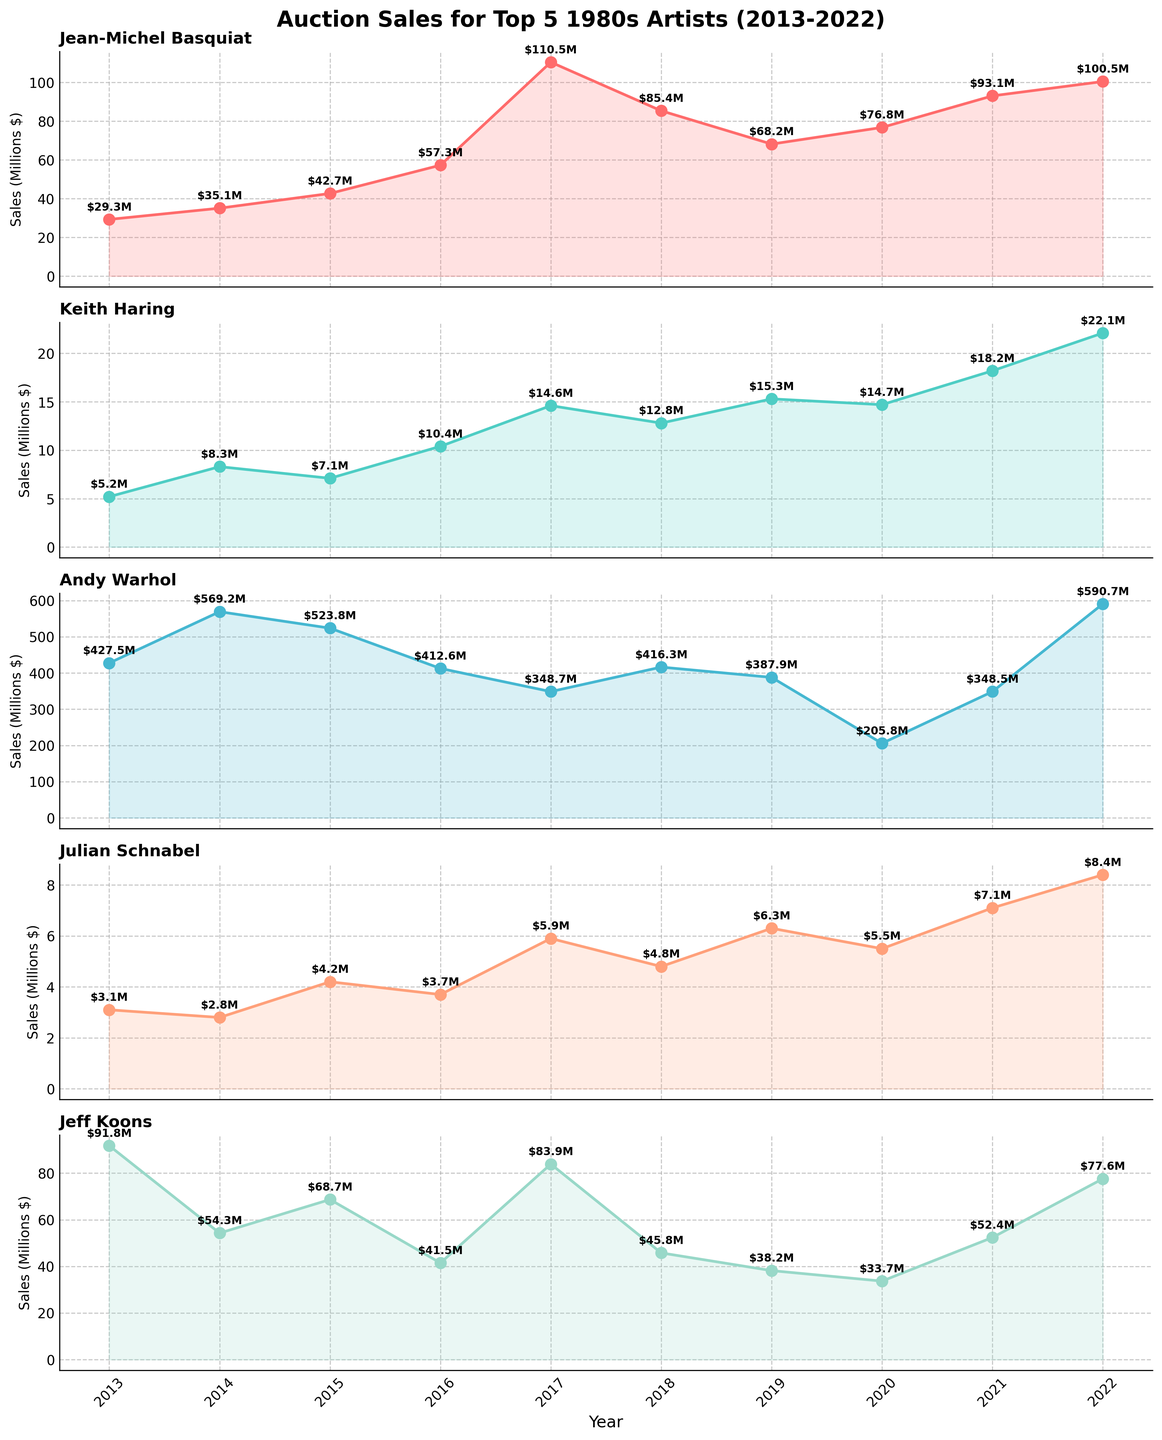What is the title of the figure? The title of the figure is located at the top and summarizes the purpose or content of the figure. It reads "Auction Sales for Top 5 1980s Artists (2013-2022)".
Answer: Auction Sales for Top 5 1980s Artists (2013-2022) What is the sales value for Jean-Michel Basquiat in 2018? Find the plot for Jean-Michel Basquiat, then locate the point for the year 2018 on the x-axis. The corresponding sales value can be read directly from the y-axis. In 2018, it’s marked as $85.4M.
Answer: $85.4M Which artist had the highest auction sales in 2022? Compare the sales values for 2022 for each artist by looking at the end of each subplot. Andy Warhol’s sales were the highest with a value of $590.7M in 2022.
Answer: Andy Warhol On average, how much did Keith Haring’s auction sales increase per year from 2013 to 2022? To find the average yearly increase, subtract the 2013 sales value from the 2022 sales value and divide by the number of years (2022-2013 = 9 years). The calculation is ($22.1M - $5.2M) / 9 years = $1.8778M per year.
Answer: $1.8778M per year Which two artists experienced the most significant drop in auction sales in any single year? By examining each subplot, identify where the most significant year-over-year drop occurred. Andy Warhol had a significant drop from 2018 to 2019 ($416.3M to $205.8M), and Jeff Koons from 2017 to 2018 ($83.9M to $45.8M).
Answer: Andy Warhol, Jeff Koons What was the total sales value for Andy Warhol over the decade? Sum the annual sales values from 2013 to 2022 for Andy Warhol: $427.5M + $569.2M + $523.8M + $412.6M + $348.7M + $416.3M + $387.9M + $205.8M + $348.5M + $590.7M = $4230M.
Answer: $4230M Which artist had the steadiest increase in auction sales over the years? Observe the slope consistency in each artist's subplot. Jean-Michel Basquiat shows a noticeable upward trend with fewer significant drops, indicating a steady increase.
Answer: Jean-Michel Basquiat In which year did Jeff Koons experience the highest auction sales? Locate the highest point in Jeff Koons' subplot and check the corresponding year on the x-axis. The highest sales occurred in 2013, with $91.8M.
Answer: 2013 